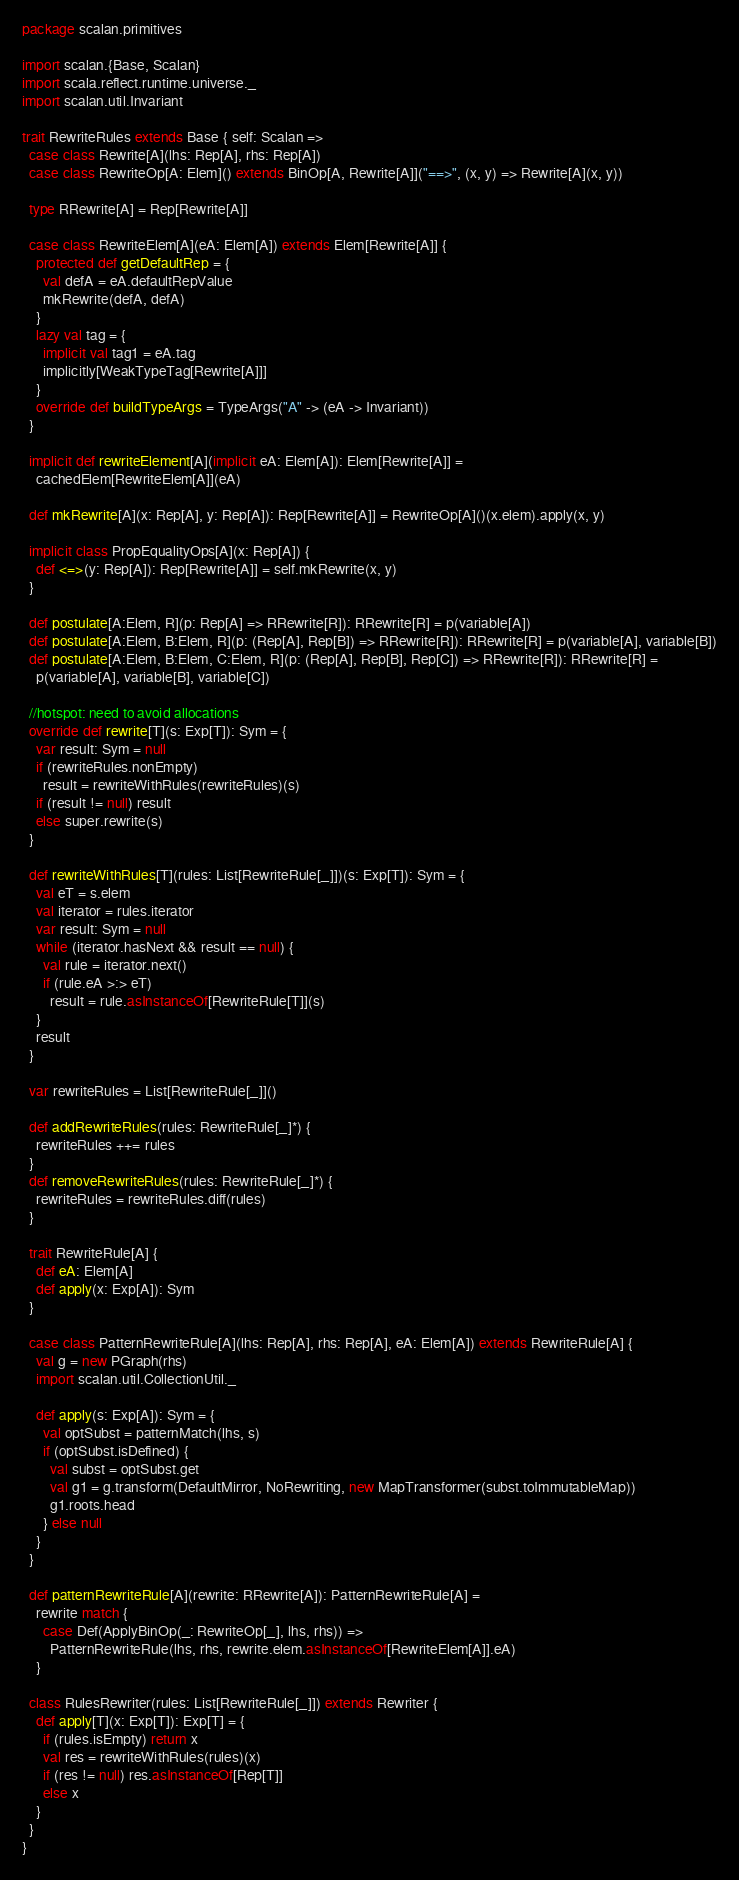Convert code to text. <code><loc_0><loc_0><loc_500><loc_500><_Scala_>package scalan.primitives

import scalan.{Base, Scalan}
import scala.reflect.runtime.universe._
import scalan.util.Invariant

trait RewriteRules extends Base { self: Scalan =>
  case class Rewrite[A](lhs: Rep[A], rhs: Rep[A])
  case class RewriteOp[A: Elem]() extends BinOp[A, Rewrite[A]]("==>", (x, y) => Rewrite[A](x, y))

  type RRewrite[A] = Rep[Rewrite[A]]

  case class RewriteElem[A](eA: Elem[A]) extends Elem[Rewrite[A]] {
    protected def getDefaultRep = {
      val defA = eA.defaultRepValue
      mkRewrite(defA, defA)
    }
    lazy val tag = {
      implicit val tag1 = eA.tag
      implicitly[WeakTypeTag[Rewrite[A]]]
    }
    override def buildTypeArgs = TypeArgs("A" -> (eA -> Invariant))
  }

  implicit def rewriteElement[A](implicit eA: Elem[A]): Elem[Rewrite[A]] =
    cachedElem[RewriteElem[A]](eA)

  def mkRewrite[A](x: Rep[A], y: Rep[A]): Rep[Rewrite[A]] = RewriteOp[A]()(x.elem).apply(x, y)

  implicit class PropEqualityOps[A](x: Rep[A]) {
    def <=>(y: Rep[A]): Rep[Rewrite[A]] = self.mkRewrite(x, y)
  }

  def postulate[A:Elem, R](p: Rep[A] => RRewrite[R]): RRewrite[R] = p(variable[A])
  def postulate[A:Elem, B:Elem, R](p: (Rep[A], Rep[B]) => RRewrite[R]): RRewrite[R] = p(variable[A], variable[B])
  def postulate[A:Elem, B:Elem, C:Elem, R](p: (Rep[A], Rep[B], Rep[C]) => RRewrite[R]): RRewrite[R] =
    p(variable[A], variable[B], variable[C])

  //hotspot: need to avoid allocations
  override def rewrite[T](s: Exp[T]): Sym = {
    var result: Sym = null
    if (rewriteRules.nonEmpty)
      result = rewriteWithRules(rewriteRules)(s)
    if (result != null) result
    else super.rewrite(s)
  }

  def rewriteWithRules[T](rules: List[RewriteRule[_]])(s: Exp[T]): Sym = {
    val eT = s.elem
    val iterator = rules.iterator
    var result: Sym = null
    while (iterator.hasNext && result == null) {
      val rule = iterator.next()
      if (rule.eA >:> eT)
        result = rule.asInstanceOf[RewriteRule[T]](s)
    }
    result
  }

  var rewriteRules = List[RewriteRule[_]]()

  def addRewriteRules(rules: RewriteRule[_]*) {
    rewriteRules ++= rules
  }
  def removeRewriteRules(rules: RewriteRule[_]*) {
    rewriteRules = rewriteRules.diff(rules)
  }

  trait RewriteRule[A] {
    def eA: Elem[A]
    def apply(x: Exp[A]): Sym
  }

  case class PatternRewriteRule[A](lhs: Rep[A], rhs: Rep[A], eA: Elem[A]) extends RewriteRule[A] {
    val g = new PGraph(rhs)
    import scalan.util.CollectionUtil._
    
    def apply(s: Exp[A]): Sym = {
      val optSubst = patternMatch(lhs, s)
      if (optSubst.isDefined) {
        val subst = optSubst.get
        val g1 = g.transform(DefaultMirror, NoRewriting, new MapTransformer(subst.toImmutableMap))
        g1.roots.head
      } else null
    }
  }

  def patternRewriteRule[A](rewrite: RRewrite[A]): PatternRewriteRule[A] =
    rewrite match {
      case Def(ApplyBinOp(_: RewriteOp[_], lhs, rhs)) =>
        PatternRewriteRule(lhs, rhs, rewrite.elem.asInstanceOf[RewriteElem[A]].eA)
    }

  class RulesRewriter(rules: List[RewriteRule[_]]) extends Rewriter {
    def apply[T](x: Exp[T]): Exp[T] = {
      if (rules.isEmpty) return x
      val res = rewriteWithRules(rules)(x)
      if (res != null) res.asInstanceOf[Rep[T]]
      else x
    }
  }
}
</code> 